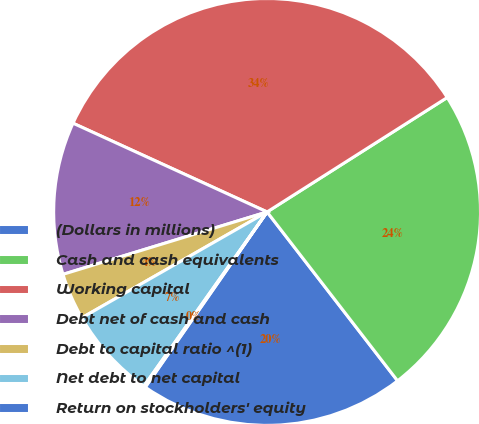<chart> <loc_0><loc_0><loc_500><loc_500><pie_chart><fcel>(Dollars in millions)<fcel>Cash and cash equivalents<fcel>Working capital<fcel>Debt net of cash and cash<fcel>Debt to capital ratio ^(1)<fcel>Net debt to net capital<fcel>Return on stockholders' equity<nl><fcel>20.14%<fcel>23.54%<fcel>34.17%<fcel>11.55%<fcel>3.54%<fcel>6.94%<fcel>0.13%<nl></chart> 